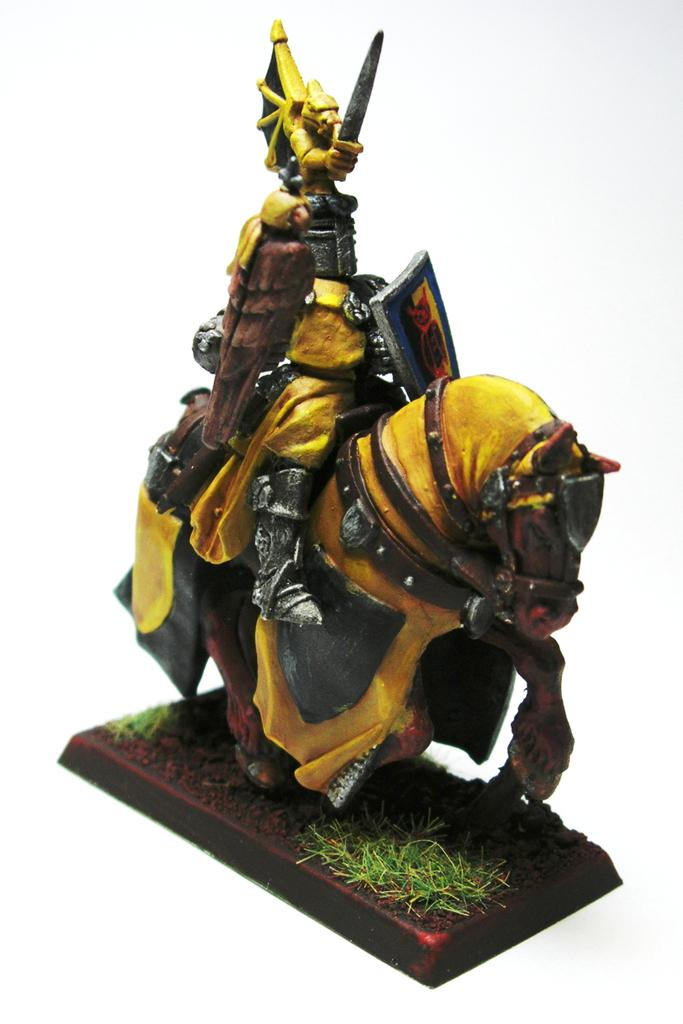What type of object is featured in the image? There is a toy sculpture in the image. What does the sculpture depict? The sculpture depicts a man. What is the man holding in the image? The man is holding a sword and an Armour. What is the man sitting on in the image? The man is sitting on a horse. What type of kettle is being used to tell a story in the image? There is no kettle present in the image, nor is there any indication of a story being told. 